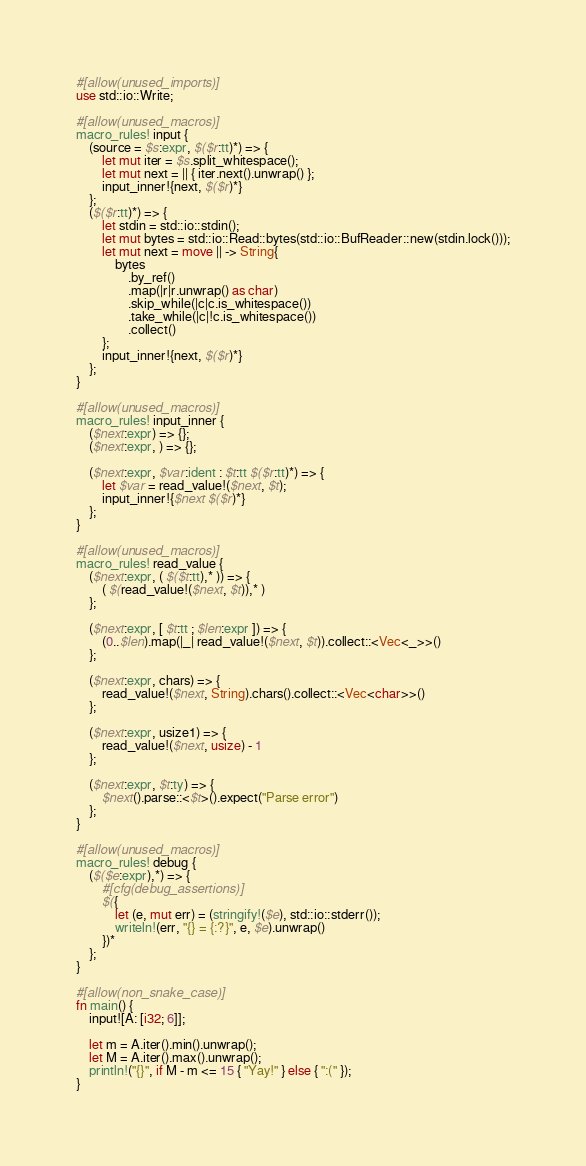Convert code to text. <code><loc_0><loc_0><loc_500><loc_500><_Rust_>#[allow(unused_imports)]
use std::io::Write;

#[allow(unused_macros)]
macro_rules! input {
    (source = $s:expr, $($r:tt)*) => {
        let mut iter = $s.split_whitespace();
        let mut next = || { iter.next().unwrap() };
        input_inner!{next, $($r)*}
    };
    ($($r:tt)*) => {
        let stdin = std::io::stdin();
        let mut bytes = std::io::Read::bytes(std::io::BufReader::new(stdin.lock()));
        let mut next = move || -> String{
            bytes
                .by_ref()
                .map(|r|r.unwrap() as char)
                .skip_while(|c|c.is_whitespace())
                .take_while(|c|!c.is_whitespace())
                .collect()
        };
        input_inner!{next, $($r)*}
    };
}

#[allow(unused_macros)]
macro_rules! input_inner {
    ($next:expr) => {};
    ($next:expr, ) => {};

    ($next:expr, $var:ident : $t:tt $($r:tt)*) => {
        let $var = read_value!($next, $t);
        input_inner!{$next $($r)*}
    };
}

#[allow(unused_macros)]
macro_rules! read_value {
    ($next:expr, ( $($t:tt),* )) => {
        ( $(read_value!($next, $t)),* )
    };

    ($next:expr, [ $t:tt ; $len:expr ]) => {
        (0..$len).map(|_| read_value!($next, $t)).collect::<Vec<_>>()
    };

    ($next:expr, chars) => {
        read_value!($next, String).chars().collect::<Vec<char>>()
    };

    ($next:expr, usize1) => {
        read_value!($next, usize) - 1
    };

    ($next:expr, $t:ty) => {
        $next().parse::<$t>().expect("Parse error")
    };
}

#[allow(unused_macros)]
macro_rules! debug {
    ($($e:expr),*) => {
        #[cfg(debug_assertions)]
        $({
            let (e, mut err) = (stringify!($e), std::io::stderr());
            writeln!(err, "{} = {:?}", e, $e).unwrap()
        })*
    };
}

#[allow(non_snake_case)]
fn main() {
    input![A: [i32; 6]];

    let m = A.iter().min().unwrap();
    let M = A.iter().max().unwrap();
    println!("{}", if M - m <= 15 { "Yay!" } else { ":(" });
}
</code> 